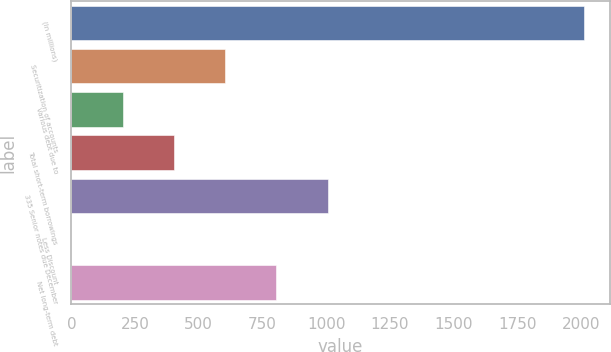Convert chart. <chart><loc_0><loc_0><loc_500><loc_500><bar_chart><fcel>(In millions)<fcel>Securitization of accounts<fcel>Various debt due to<fcel>Total short-term borrowings<fcel>335 Senior notes due December<fcel>Less Discount<fcel>Net long-term debt<nl><fcel>2011<fcel>603.51<fcel>201.37<fcel>402.44<fcel>1005.65<fcel>0.3<fcel>804.58<nl></chart> 